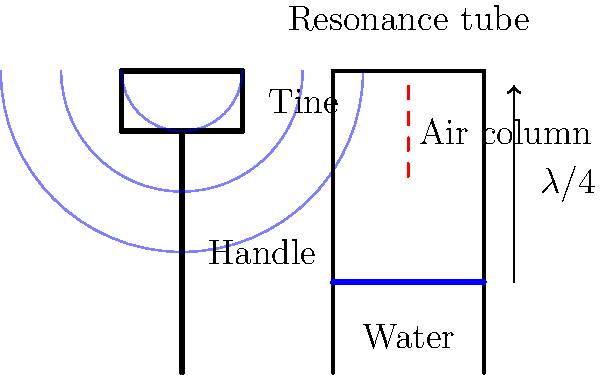In the diagram, a tuning fork is placed above a resonance tube partially filled with water. When the fork vibrates at its fundamental frequency, it produces a standing wave in the air column. If the length of the air column is exactly one-quarter of the wavelength of the sound produced by the tuning fork, what is the relationship between the frequency of the tuning fork and the length of the air column? To understand the relationship between the frequency of the tuning fork and the length of the air column, we need to follow these steps:

1. Recall the relationship between wavelength ($\lambda$), frequency ($f$), and speed of sound ($v$):
   $$v = f\lambda$$

2. In this case, the length of the air column ($L$) is one-quarter of the wavelength:
   $$L = \frac{\lambda}{4}$$

3. Rearrange this equation to express wavelength in terms of the air column length:
   $$\lambda = 4L$$

4. Substitute this into the wave equation from step 1:
   $$v = f(4L)$$

5. Rearrange to isolate frequency:
   $$f = \frac{v}{4L}$$

6. The speed of sound ($v$) is constant for a given temperature and medium. Therefore, we can see that the frequency ($f$) is inversely proportional to the length of the air column ($L$).

This relationship demonstrates that as the length of the air column increases, the frequency of resonance decreases, and vice versa. This principle is fundamental in understanding how wind instruments and organ pipes produce different pitches.
Answer: $f = \frac{v}{4L}$ 